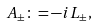Convert formula to latex. <formula><loc_0><loc_0><loc_500><loc_500>A _ { \pm } \colon = - i L _ { \pm } ,</formula> 